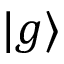<formula> <loc_0><loc_0><loc_500><loc_500>| g \rangle</formula> 